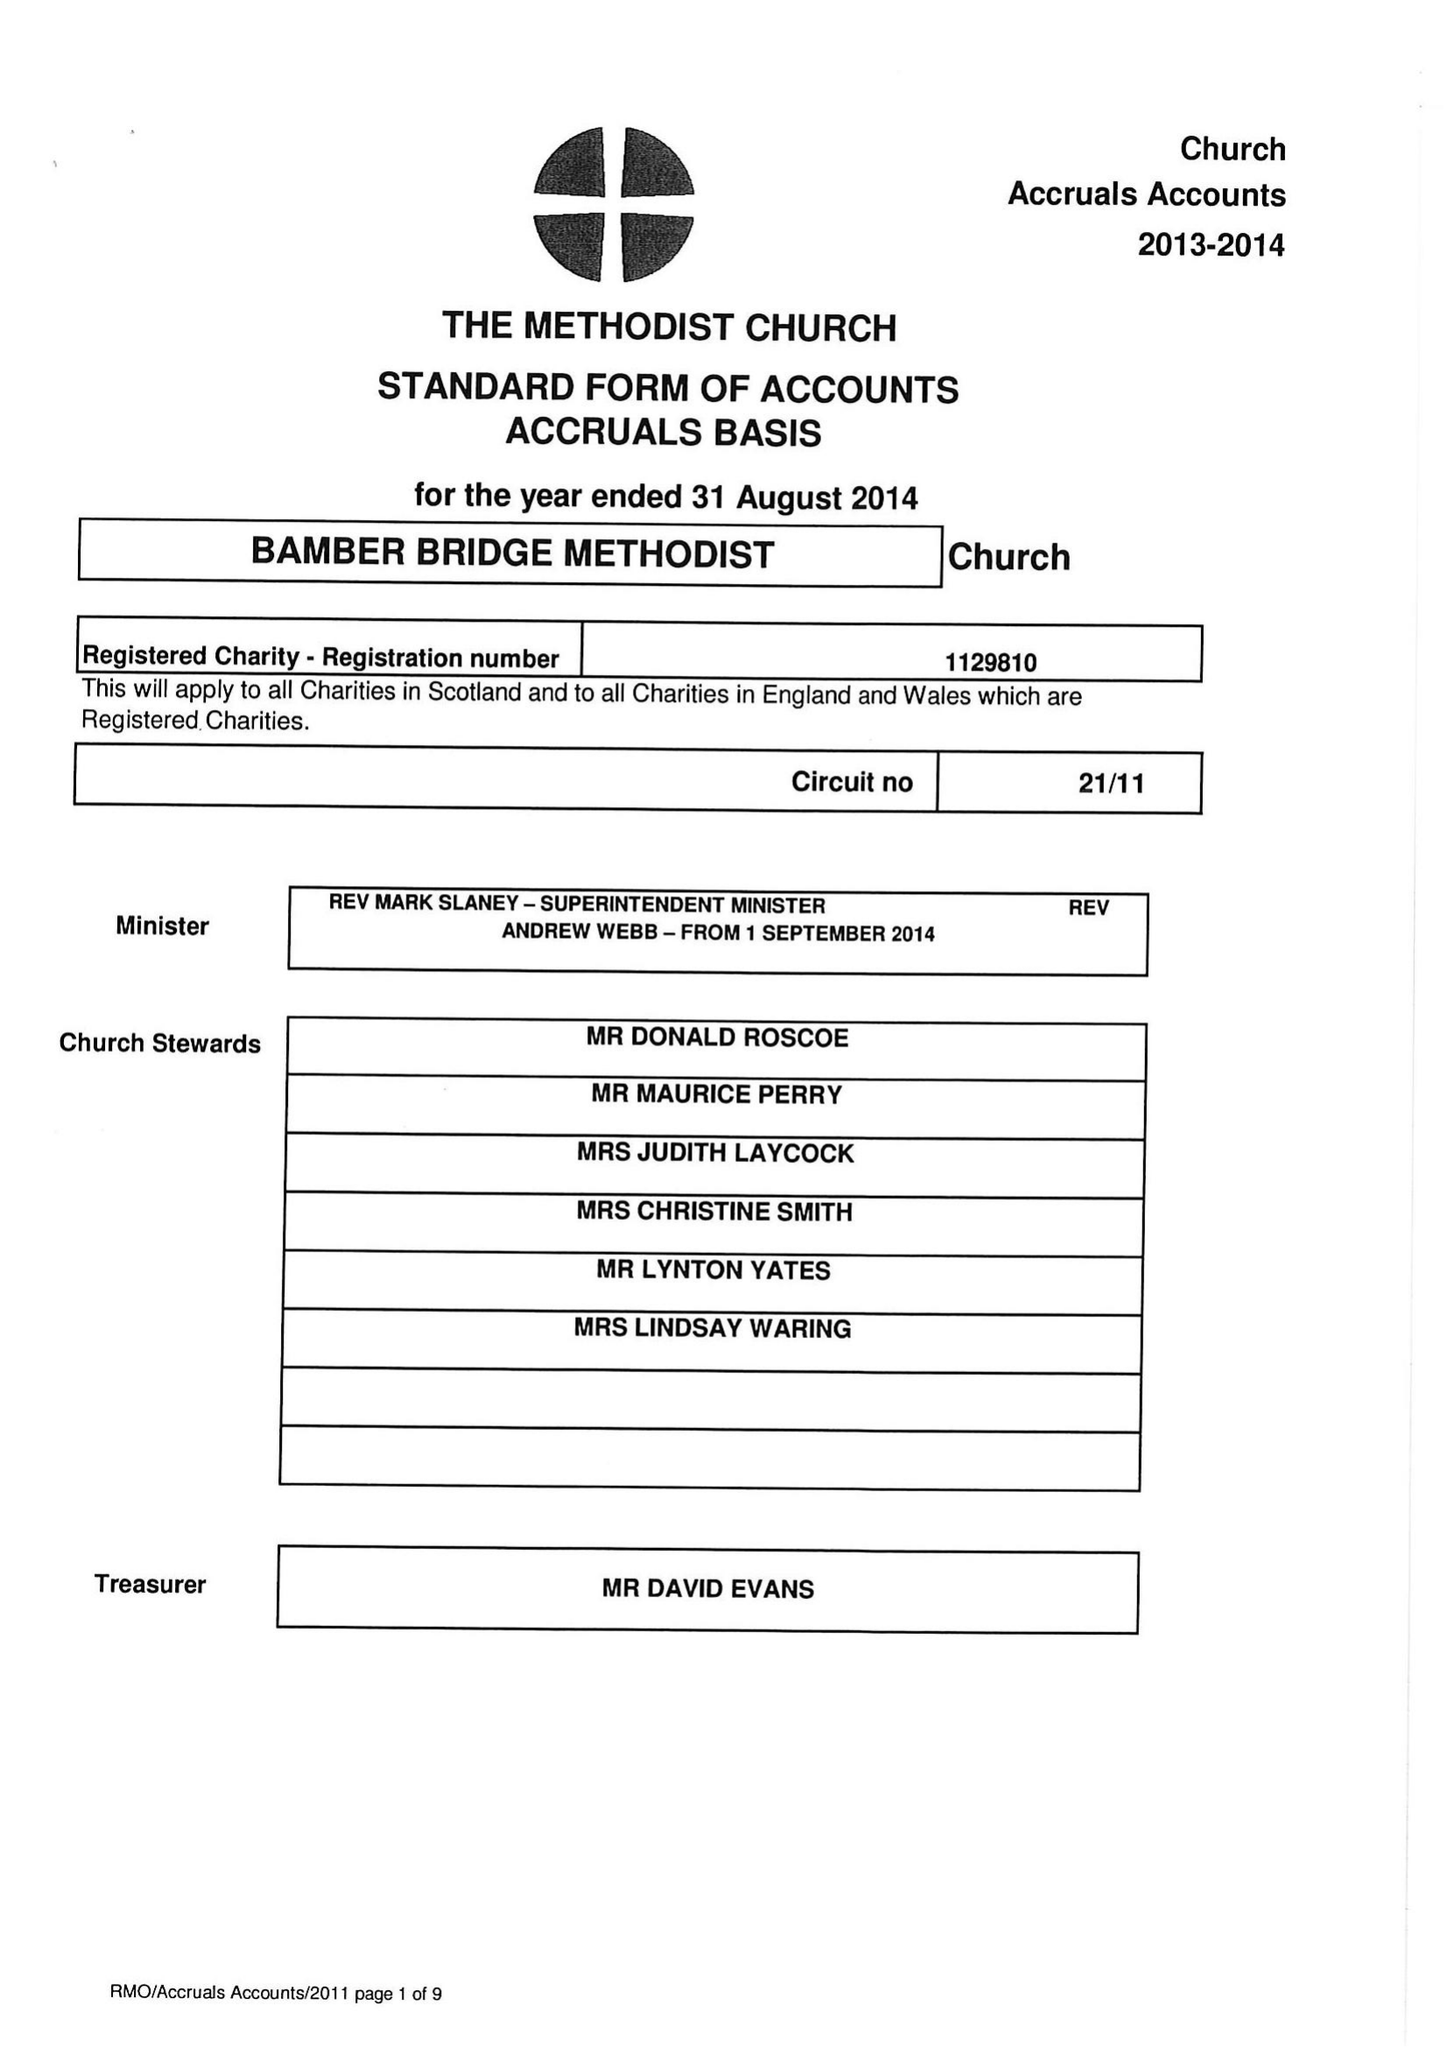What is the value for the address__postcode?
Answer the question using a single word or phrase. PR5 6ED 